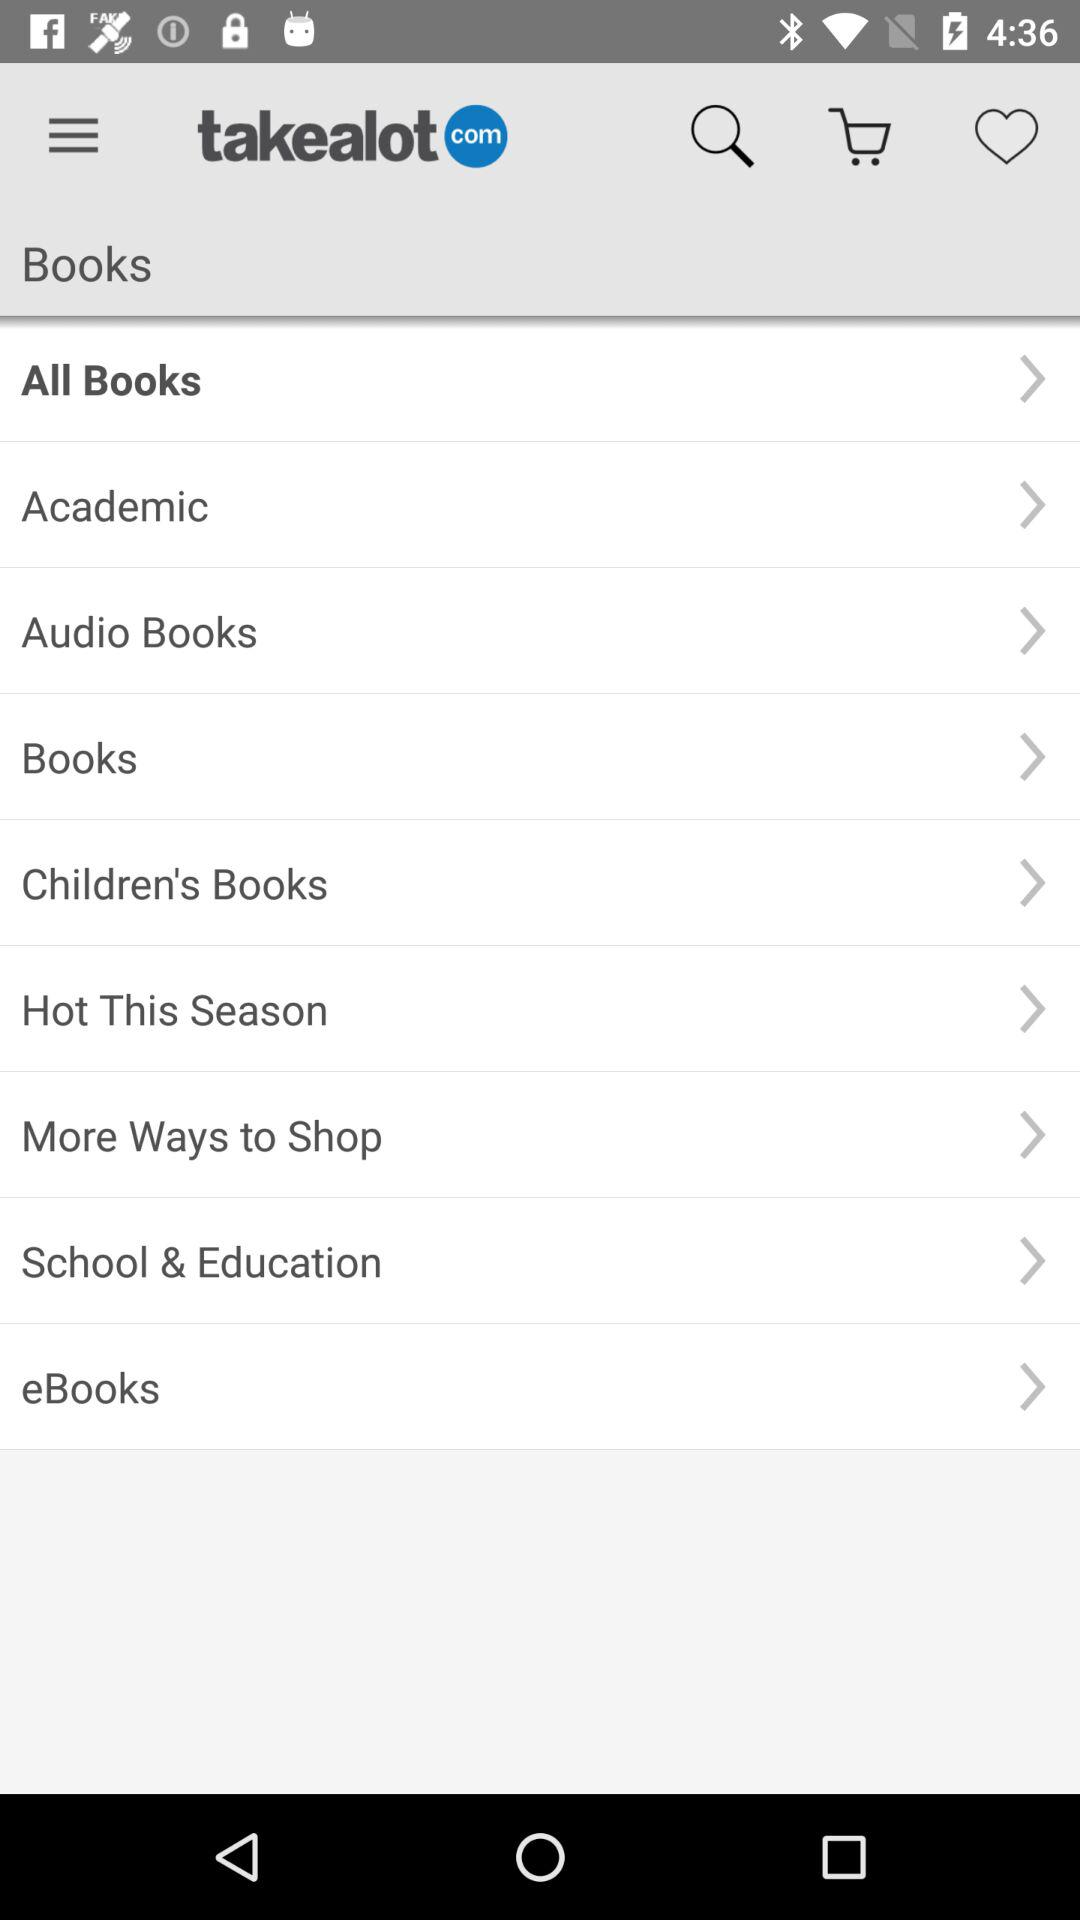Which option has been selected? The selected option is "All Books". 